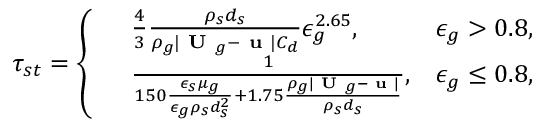Convert formula to latex. <formula><loc_0><loc_0><loc_500><loc_500>\tau _ { s t } = \left \{ \begin{array} { r l r } & { \frac { 4 } { 3 } \frac { \rho _ { s } d _ { s } } { \rho _ { g } | U _ { g } - u | C _ { d } } \epsilon _ { g } ^ { 2 . 6 5 } , } & { \epsilon _ { g } > 0 . 8 , } \\ & { \frac { 1 } { 1 5 0 \frac { \epsilon _ { s } \mu _ { g } } { \epsilon _ { g } \rho _ { s } d _ { s } ^ { 2 } } + 1 . 7 5 \frac { \rho _ { g } | U _ { g } - u | } { \rho _ { s } d _ { s } } } , } & { \epsilon _ { g } \leq 0 . 8 , } \end{array}</formula> 